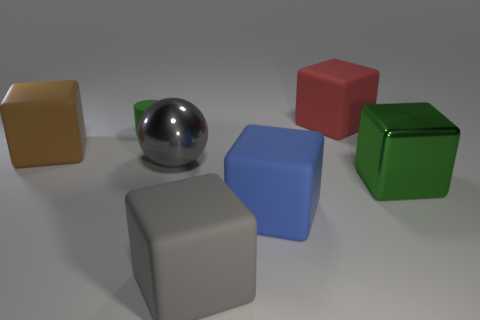Add 3 small cylinders. How many objects exist? 10 Subtract all cubes. How many objects are left? 2 Subtract 1 blocks. How many blocks are left? 4 Subtract all gray cylinders. Subtract all brown balls. How many cylinders are left? 1 Subtract all blue blocks. How many gray cylinders are left? 0 Subtract all small things. Subtract all red objects. How many objects are left? 5 Add 4 big blue matte cubes. How many big blue matte cubes are left? 5 Add 1 big rubber objects. How many big rubber objects exist? 5 Subtract all green cubes. How many cubes are left? 4 Subtract all big red blocks. How many blocks are left? 4 